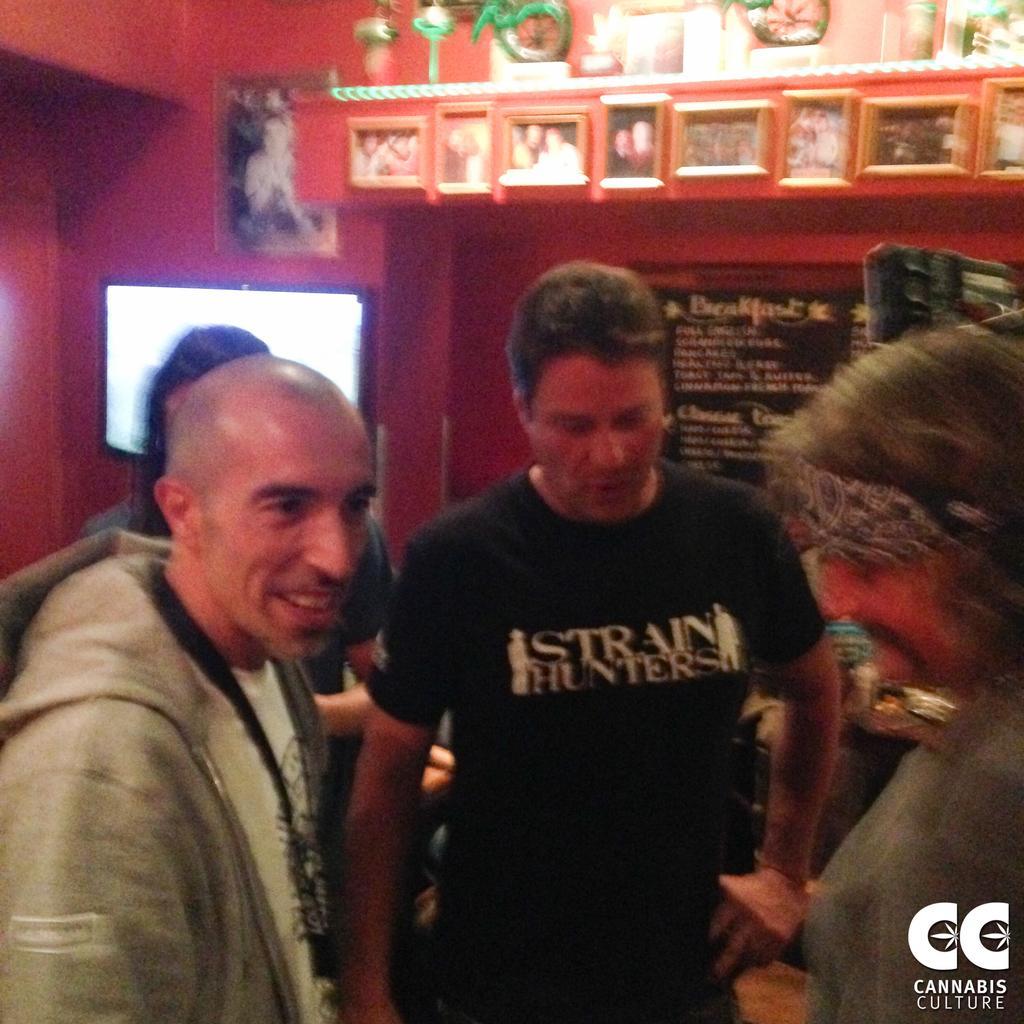In one or two sentences, can you explain what this image depicts? In this image we can see few people. In the background there is a wall. On the wall there are photo frames. Also there are some decorative items. And there is a screen. Also there is a board with something written. In the right bottom corner something is written. 